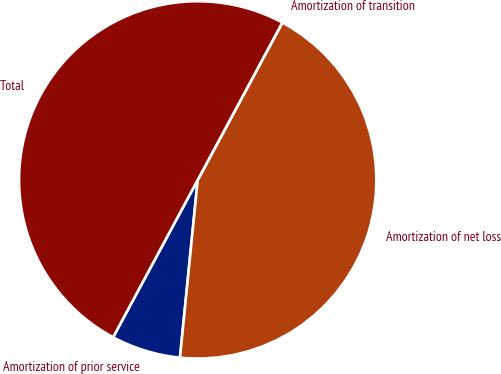<chart> <loc_0><loc_0><loc_500><loc_500><pie_chart><fcel>Amortization of prior service<fcel>Amortization of net loss<fcel>Amortization of transition<fcel>Total<nl><fcel>6.27%<fcel>43.73%<fcel>0.0%<fcel>50.0%<nl></chart> 